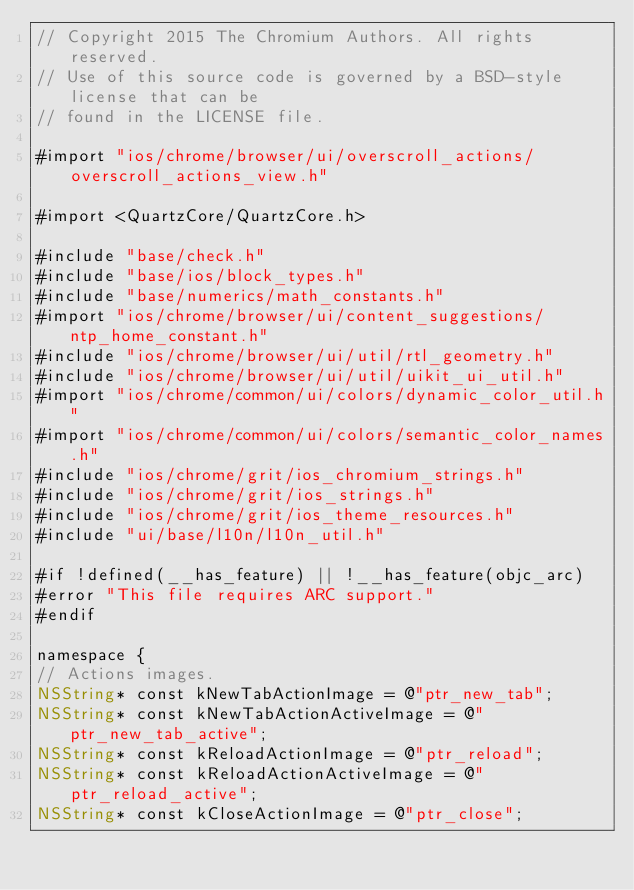<code> <loc_0><loc_0><loc_500><loc_500><_ObjectiveC_>// Copyright 2015 The Chromium Authors. All rights reserved.
// Use of this source code is governed by a BSD-style license that can be
// found in the LICENSE file.

#import "ios/chrome/browser/ui/overscroll_actions/overscroll_actions_view.h"

#import <QuartzCore/QuartzCore.h>

#include "base/check.h"
#include "base/ios/block_types.h"
#include "base/numerics/math_constants.h"
#import "ios/chrome/browser/ui/content_suggestions/ntp_home_constant.h"
#include "ios/chrome/browser/ui/util/rtl_geometry.h"
#include "ios/chrome/browser/ui/util/uikit_ui_util.h"
#import "ios/chrome/common/ui/colors/dynamic_color_util.h"
#import "ios/chrome/common/ui/colors/semantic_color_names.h"
#include "ios/chrome/grit/ios_chromium_strings.h"
#include "ios/chrome/grit/ios_strings.h"
#include "ios/chrome/grit/ios_theme_resources.h"
#include "ui/base/l10n/l10n_util.h"

#if !defined(__has_feature) || !__has_feature(objc_arc)
#error "This file requires ARC support."
#endif

namespace {
// Actions images.
NSString* const kNewTabActionImage = @"ptr_new_tab";
NSString* const kNewTabActionActiveImage = @"ptr_new_tab_active";
NSString* const kReloadActionImage = @"ptr_reload";
NSString* const kReloadActionActiveImage = @"ptr_reload_active";
NSString* const kCloseActionImage = @"ptr_close";</code> 